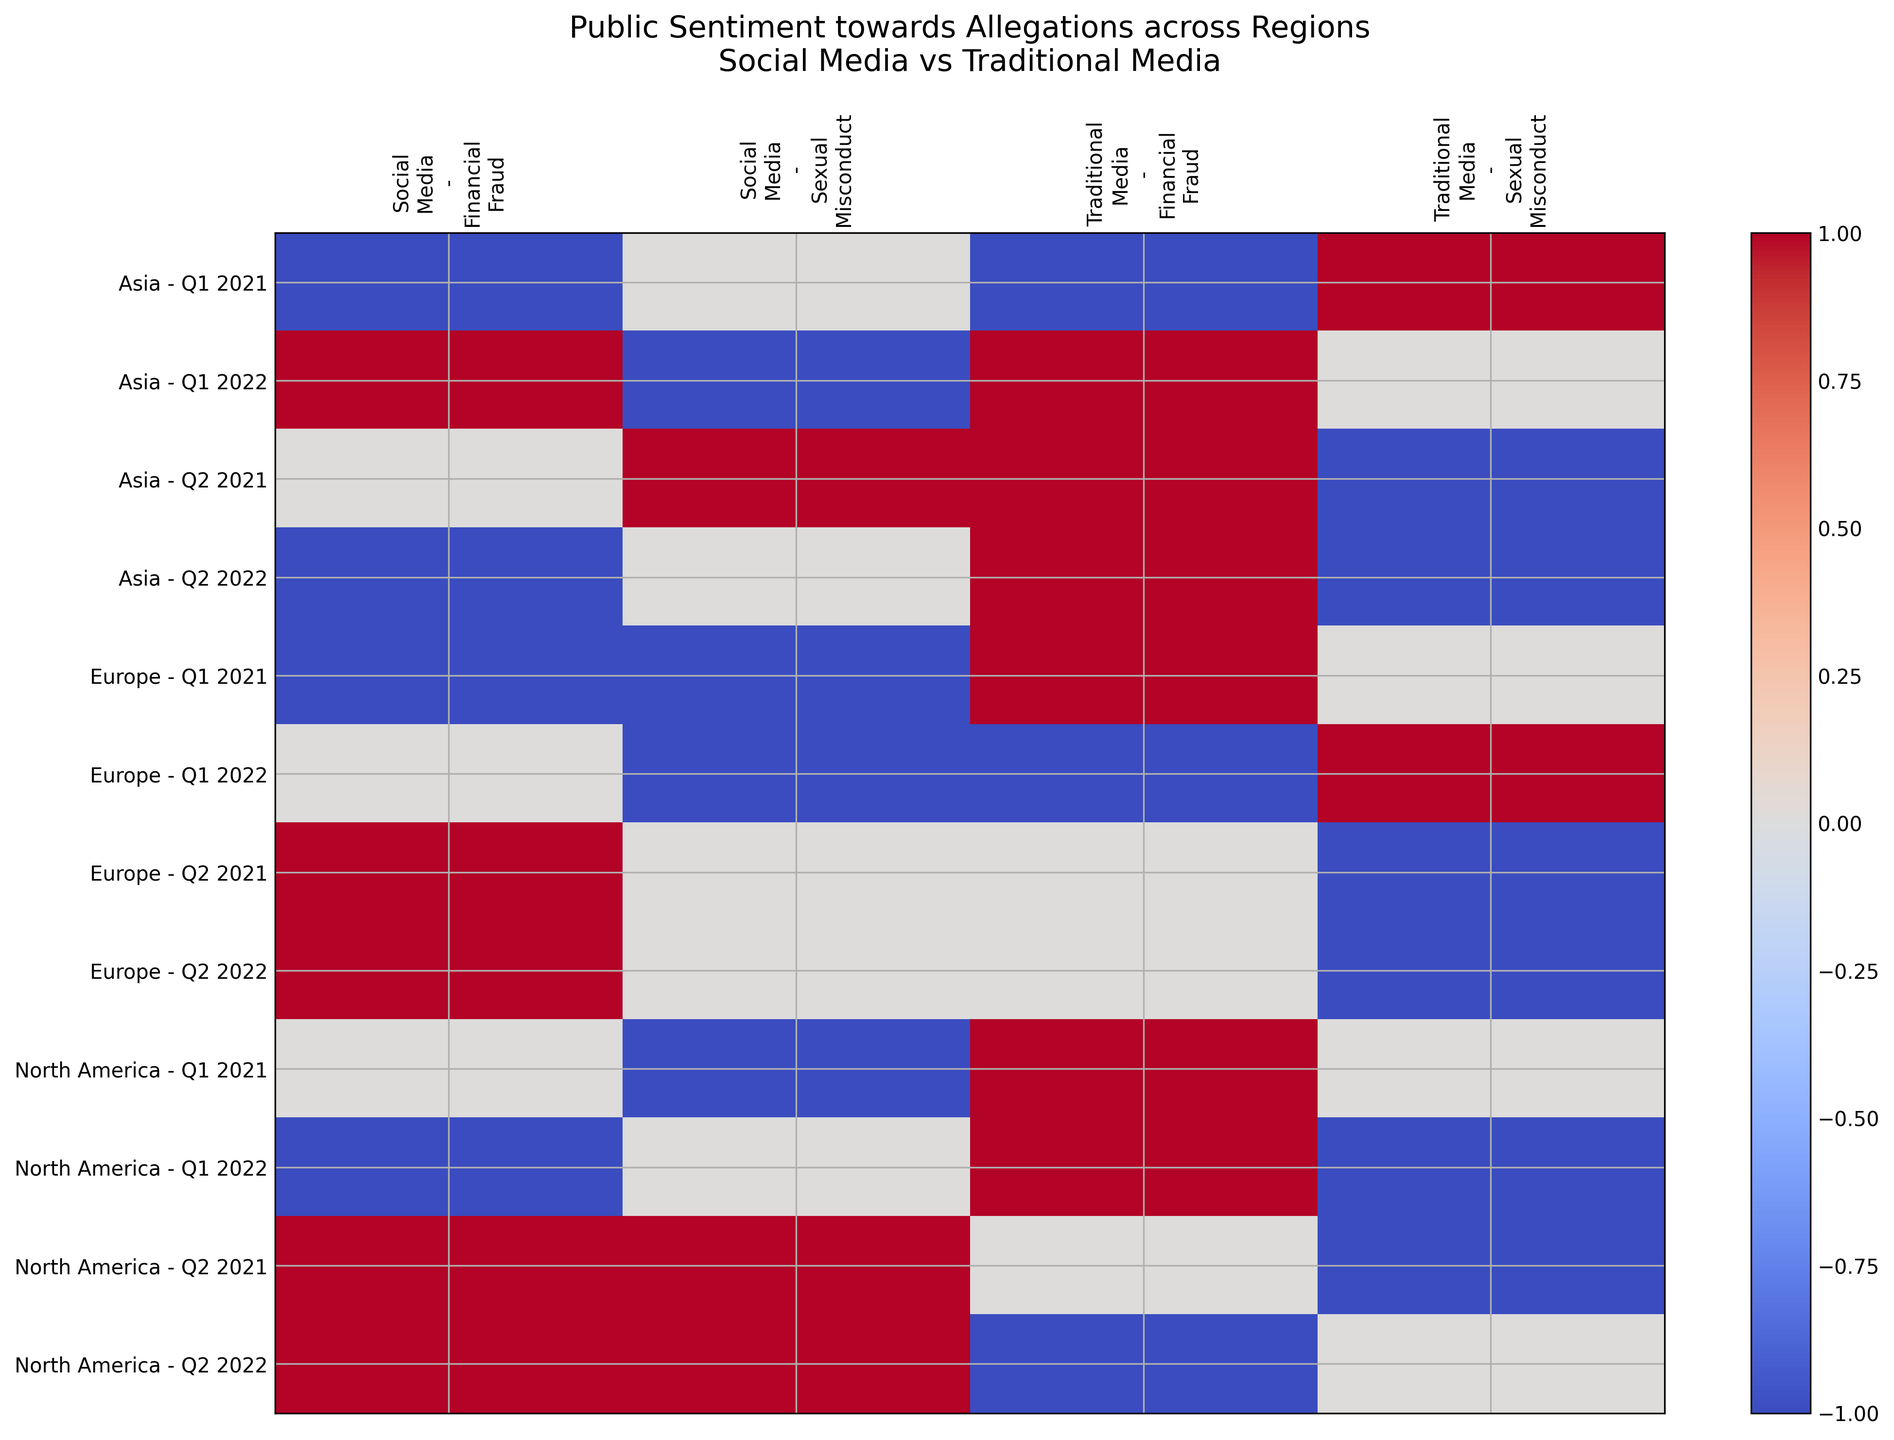How does public sentiment towards financial fraud allegations differ between social media and traditional media in Q1 2021 in Europe? Look at the rows corresponding to Europe and the columns for Q1 2021. Compare the sentiment under social media and traditional media for financial fraud allegations. Social media shows a negative sentiment, while traditional media shows a positive sentiment.
Answer: Social media: Negative, Traditional media: Positive How did public sentiment towards sexual misconduct allegations on social media in North America change from Q1 to Q2 in 2021? Look at the columns for Q1 2021 and Q2 2021 under North America and compare the change in sentiment for social media regarding sexual misconduct allegations. The sentiment changed from negative to positive.
Answer: Negative to Positive Which region exhibited the most positive sentiment on social media for financial fraud allegations in Q2 2021? Look at the rows for Q2 2021 across all regions and check the sentiment for financial fraud allegations on social media. Both North America and Europe exhibit positive sentiment.
Answer: North America and Europe Compare the sentiment of traditional media and social media towards allegations of sexual misconduct in Asia for Q2 2022. Look at the rows corresponding to Asia in Q2 2022. Compare the sentiment under social media and traditional media for sexual misconduct. Social media shows a neutral sentiment, while traditional media shows a negative sentiment.
Answer: Social media: Neutral, Traditional media: Negative Overall, in North America, did social media or traditional media have a more positive sentiment towards sexual misconduct allegations in Q1 2022? Check the rows corresponding to North America in Q1 2022 and compare the sentiment of social media with traditional media for sexual misconduct. Social media has a neutral sentiment, while traditional media has a negative sentiment.
Answer: Social media: Neutral, Traditional media: Negative What was the most common trend in sentiment for allegations of financial fraud on traditional media from Q1 to Q2 in 2021 across all regions? Examine the sentiment for financial fraud allegations in traditional media from Q1 to Q2 2021 in North America, Europe, and Asia. In all regions, the sentiment generally changes from positive or negative in Q1 to neutral in Q2.
Answer: Neutral in Q2 Which region and media type had the most negative sentiment towards sexual misconduct allegations in Q1 2021? Look at the rows for Q1 2021 across all regions and both media types. Europe and social media had the most negative sentiment towards sexual misconduct allegations.
Answer: Europe, Social media In which regions was the sentiment towards financial fraud allegations in traditional media negative in Q2 2022? Check the rows corresponding to Q2 2022 across all regions for traditional media sentiment towards financial fraud allegations. Sentiment is negative in North America.
Answer: North America How did the sentiment towards sexual misconduct allegations on traditional media change from Q1 2021 to Q1 2022 in Europe? Compare the sentiment for sexual misconduct allegations in traditional media in Europe for Q1 2021 and Q1 2022. The sentiment changed from neutral to positive.
Answer: Neutral to Positive What is the prevalent sentiment for sexual misconduct allegations on social media during Q1 2021 across all regions? Examine the sentiment for sexual misconduct allegations on social media during Q1 2021 for North America, Europe, and Asia. The prevalent sentiment is negative (North America and Europe) and neutral (Asia).
Answer: Negative 